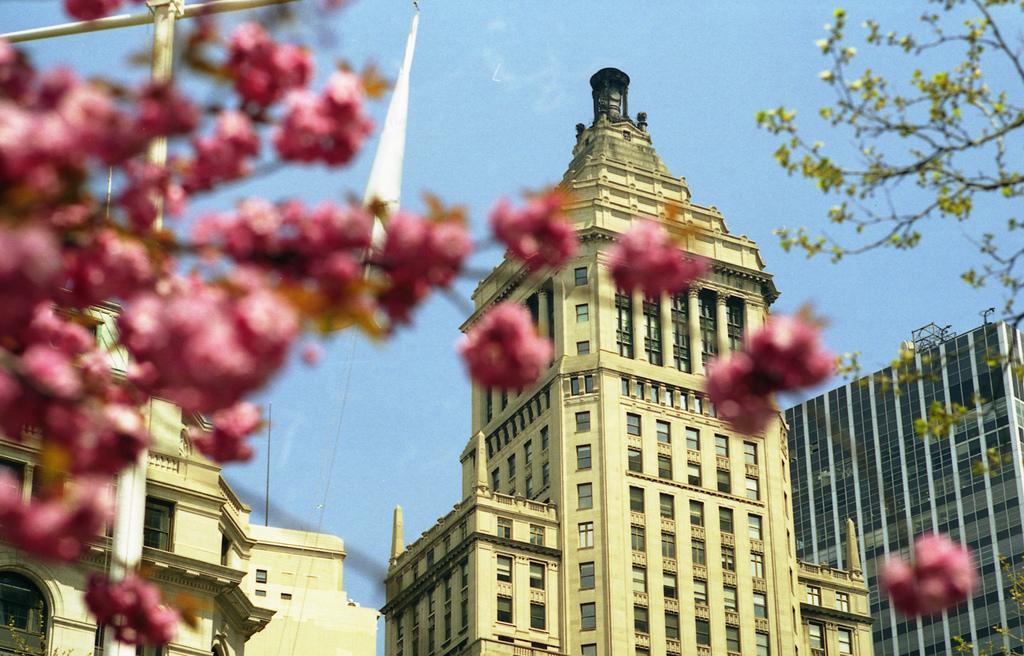Can you describe this image briefly? This image is taken outdoors. At the top of the image there is the sky. In the middle of the image there are three buildings with walls, windows, doors and roofs. There is a flag. On the left side of the image there is a tree with flowers and there is a pole. On the right side of the image there is a tree with green leaves, stems and branches. 